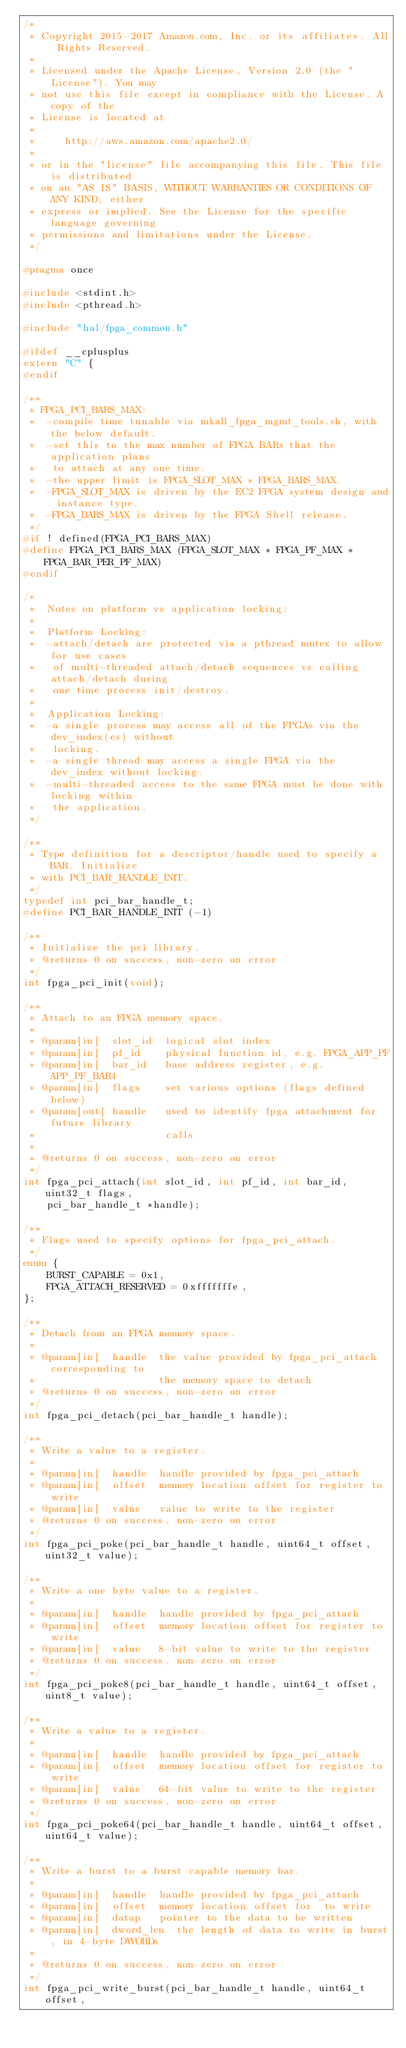<code> <loc_0><loc_0><loc_500><loc_500><_C_>/*
 * Copyright 2015-2017 Amazon.com, Inc. or its affiliates. All Rights Reserved.
 *
 * Licensed under the Apache License, Version 2.0 (the "License"). You may
 * not use this file except in compliance with the License. A copy of the
 * License is located at
 *
 *     http://aws.amazon.com/apache2.0/
 *
 * or in the "license" file accompanying this file. This file is distributed
 * on an "AS IS" BASIS, WITHOUT WARRANTIES OR CONDITIONS OF ANY KIND, either
 * express or implied. See the License for the specific language governing
 * permissions and limitations under the License.
 */

#pragma once

#include <stdint.h>
#include <pthread.h>

#include "hal/fpga_common.h"

#ifdef __cplusplus
extern "C" {
#endif

/**
 * FPGA_PCI_BARS_MAX:
 *  -compile time tunable via mkall_fpga_mgmt_tools.sh, with the below default.
 *  -set this to the max number of FPGA BARs that the application plans
 *   to attach at any one time.
 *  -the upper limit is FPGA_SLOT_MAX * FPGA_BARS_MAX.
 *  -FPGA_SLOT_MAX is driven by the EC2 FPGA system design and instance type.
 *  -FPGA_BARS_MAX is driven by the FPGA Shell release.
 */
#if ! defined(FPGA_PCI_BARS_MAX)
#define FPGA_PCI_BARS_MAX	(FPGA_SLOT_MAX * FPGA_PF_MAX * FPGA_BAR_PER_PF_MAX)
#endif

/*
 *  Notes on platform vs application locking:
 *
 *  Platform Locking:
 *  -attach/detach are protected via a pthread mutex to allow for use cases
 *   of multi-threaded attach/detach sequences vs calling attach/detach during
 *   one time process init/destroy.
 *
 *  Application Locking:
 *  -a single process may access all of the FPGAs via the dev_index(es) without
 *   locking.
 *  -a single thread may access a single FPGA via the dev_index without locking.
 *  -multi-threaded access to the same FPGA must be done with locking within
 *   the application.
 */

/**
 * Type definition for a descriptor/handle used to specify a BAR. Initialize
 * with PCI_BAR_HANDLE_INIT.
 */
typedef int pci_bar_handle_t;
#define PCI_BAR_HANDLE_INIT (-1)

/**
 * Initialize the pci library.
 * @returns 0 on success, non-zero on error
 */
int fpga_pci_init(void);

/**
 * Attach to an FPGA memory space.
 *
 * @param[in]  slot_id  logical slot index
 * @param[in]  pf_id    physical function id, e.g. FPGA_APP_PF
 * @param[in]  bar_id   base address register, e.g. APP_PF_BAR4
 * @param[in]  flags    set various options (flags defined below)
 * @param[out] handle   used to identify fpga attachment for future library
 *                      calls
 *
 * @returns 0 on success, non-zero on error
 */
int fpga_pci_attach(int slot_id, int pf_id, int bar_id, uint32_t flags,
    pci_bar_handle_t *handle);

/**
 * Flags used to specify options for fpga_pci_attach.
 */
enum {
    BURST_CAPABLE = 0x1,
    FPGA_ATTACH_RESERVED = 0xfffffffe,
};

/**
 * Detach from an FPGA memory space.
 *
 * @param[in]  handle  the value provided by fpga_pci_attach corresponding to
 *                     the memory space to detach
 * @returns 0 on success, non-zero on error
 */
int fpga_pci_detach(pci_bar_handle_t handle);

/**
 * Write a value to a register.
 *
 * @param[in]  handle  handle provided by fpga_pci_attach
 * @param[in]  offset  memory location offset for register to write
 * @param[in]  value   value to write to the register
 * @returns 0 on success, non-zero on error
 */
int fpga_pci_poke(pci_bar_handle_t handle, uint64_t offset, uint32_t value);

/**
 * Write a one byte value to a register.
 *
 * @param[in]  handle  handle provided by fpga_pci_attach
 * @param[in]  offset  memory location offset for register to write
 * @param[in]  value   8-bit value to write to the register
 * @returns 0 on success, non-zero on error
 */
int fpga_pci_poke8(pci_bar_handle_t handle, uint64_t offset, uint8_t value);

/**
 * Write a value to a register.
 *
 * @param[in]  handle  handle provided by fpga_pci_attach
 * @param[in]  offset  memory location offset for register to write
 * @param[in]  value   64-bit value to write to the register
 * @returns 0 on success, non-zero on error
 */
int fpga_pci_poke64(pci_bar_handle_t handle, uint64_t offset, uint64_t value);

/**
 * Write a burst to a burst capable memory bar.
 *
 * @param[in]  handle  handle provided by fpga_pci_attach
 * @param[in]  offset  memory location offset for  to write
 * @param[in]  datap   pointer to the data to be written
 * @param[in]  dword_len  the length of data to write in burst, in 4-byte DWORDs
 *
 * @returns 0 on success, non-zero on error
 */
int fpga_pci_write_burst(pci_bar_handle_t handle, uint64_t offset,</code> 